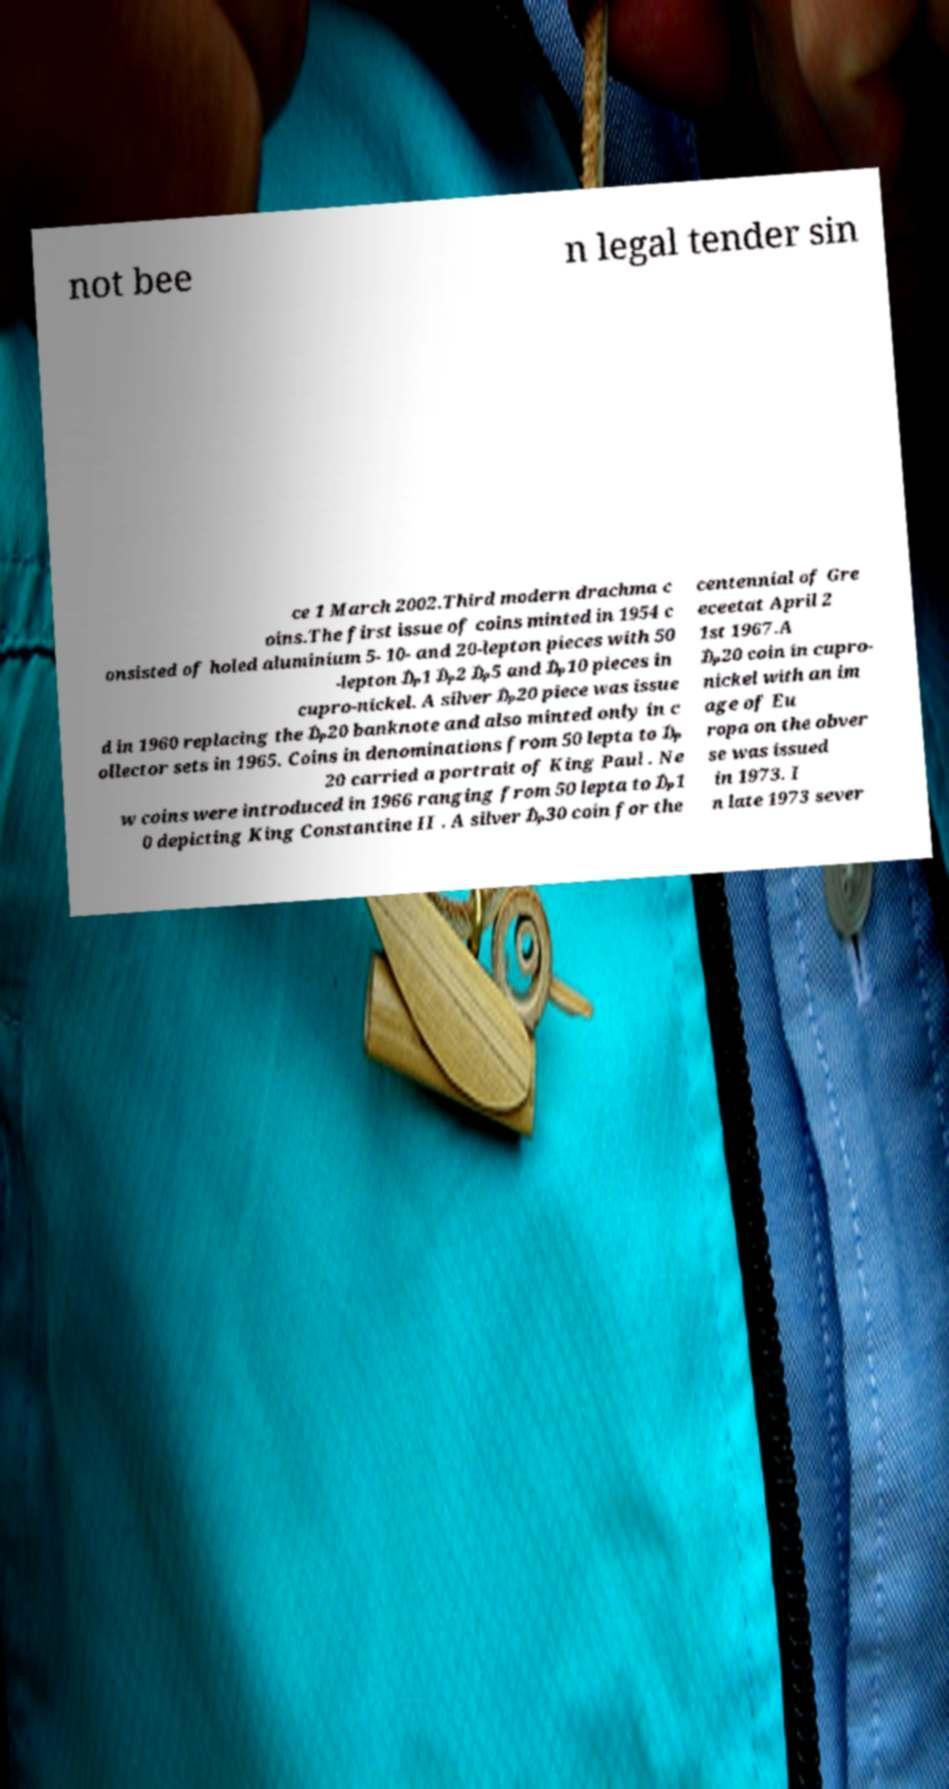Please read and relay the text visible in this image. What does it say? not bee n legal tender sin ce 1 March 2002.Third modern drachma c oins.The first issue of coins minted in 1954 c onsisted of holed aluminium 5- 10- and 20-lepton pieces with 50 -lepton ₯1 ₯2 ₯5 and ₯10 pieces in cupro-nickel. A silver ₯20 piece was issue d in 1960 replacing the ₯20 banknote and also minted only in c ollector sets in 1965. Coins in denominations from 50 lepta to ₯ 20 carried a portrait of King Paul . Ne w coins were introduced in 1966 ranging from 50 lepta to ₯1 0 depicting King Constantine II . A silver ₯30 coin for the centennial of Gre eceetat April 2 1st 1967.A ₯20 coin in cupro- nickel with an im age of Eu ropa on the obver se was issued in 1973. I n late 1973 sever 